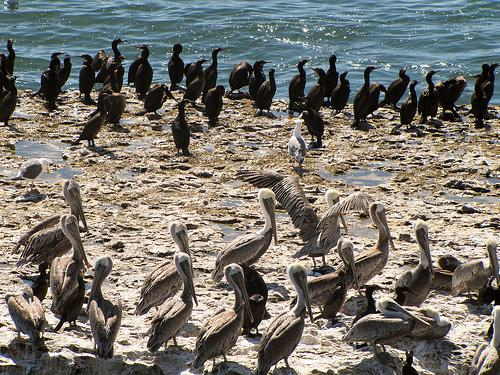Question: what are the colors of the birds?
Choices:
A. Grey and white.
B. Black.
C. Blue and brown.
D. Brown and white.
Answer with the letter. Answer: D 